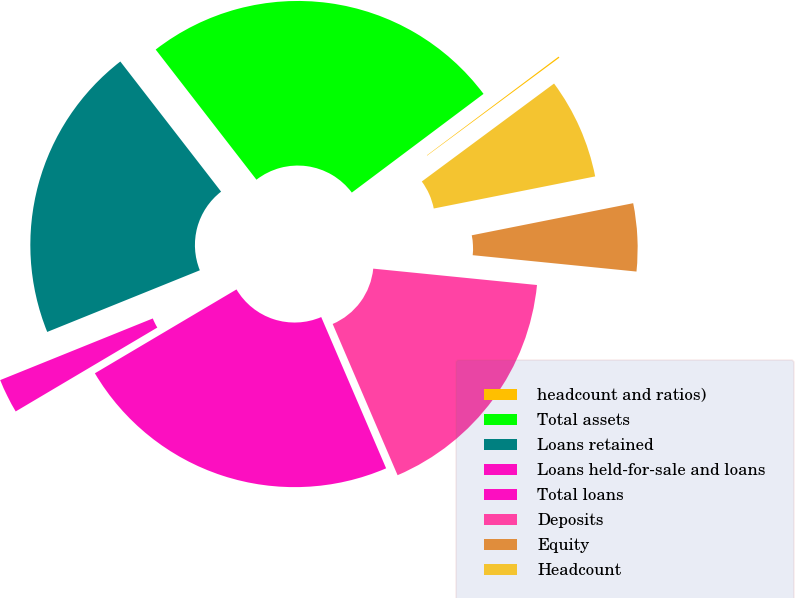Convert chart. <chart><loc_0><loc_0><loc_500><loc_500><pie_chart><fcel>headcount and ratios)<fcel>Total assets<fcel>Loans retained<fcel>Loans held-for-sale and loans<fcel>Total loans<fcel>Deposits<fcel>Equity<fcel>Headcount<nl><fcel>0.09%<fcel>25.25%<fcel>20.62%<fcel>2.4%<fcel>22.94%<fcel>16.96%<fcel>4.71%<fcel>7.02%<nl></chart> 